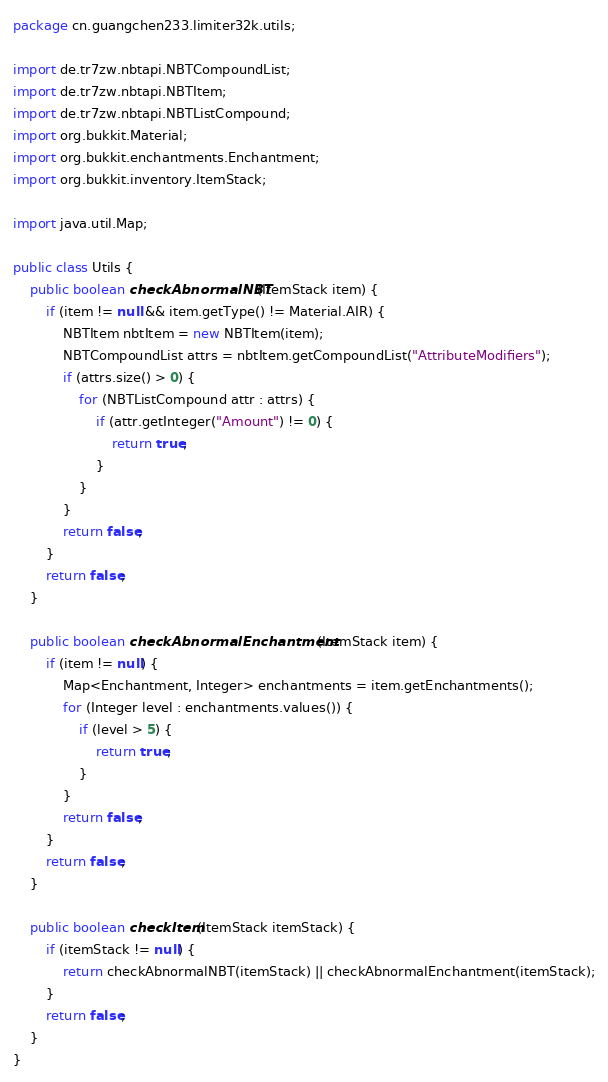<code> <loc_0><loc_0><loc_500><loc_500><_Java_>package cn.guangchen233.limiter32k.utils;

import de.tr7zw.nbtapi.NBTCompoundList;
import de.tr7zw.nbtapi.NBTItem;
import de.tr7zw.nbtapi.NBTListCompound;
import org.bukkit.Material;
import org.bukkit.enchantments.Enchantment;
import org.bukkit.inventory.ItemStack;

import java.util.Map;

public class Utils {
    public boolean checkAbnormalNBT(ItemStack item) {
        if (item != null && item.getType() != Material.AIR) {
            NBTItem nbtItem = new NBTItem(item);
            NBTCompoundList attrs = nbtItem.getCompoundList("AttributeModifiers");
            if (attrs.size() > 0) {
                for (NBTListCompound attr : attrs) {
                    if (attr.getInteger("Amount") != 0) {
                        return true;
                    }
                }
            }
            return false;
        }
        return false;
    }

    public boolean checkAbnormalEnchantment(ItemStack item) {
        if (item != null) {
            Map<Enchantment, Integer> enchantments = item.getEnchantments();
            for (Integer level : enchantments.values()) {
                if (level > 5) {
                    return true;
                }
            }
            return false;
        }
        return false;
    }

    public boolean checkItem(ItemStack itemStack) {
        if (itemStack != null) {
            return checkAbnormalNBT(itemStack) || checkAbnormalEnchantment(itemStack);
        }
        return false;
    }
}
</code> 